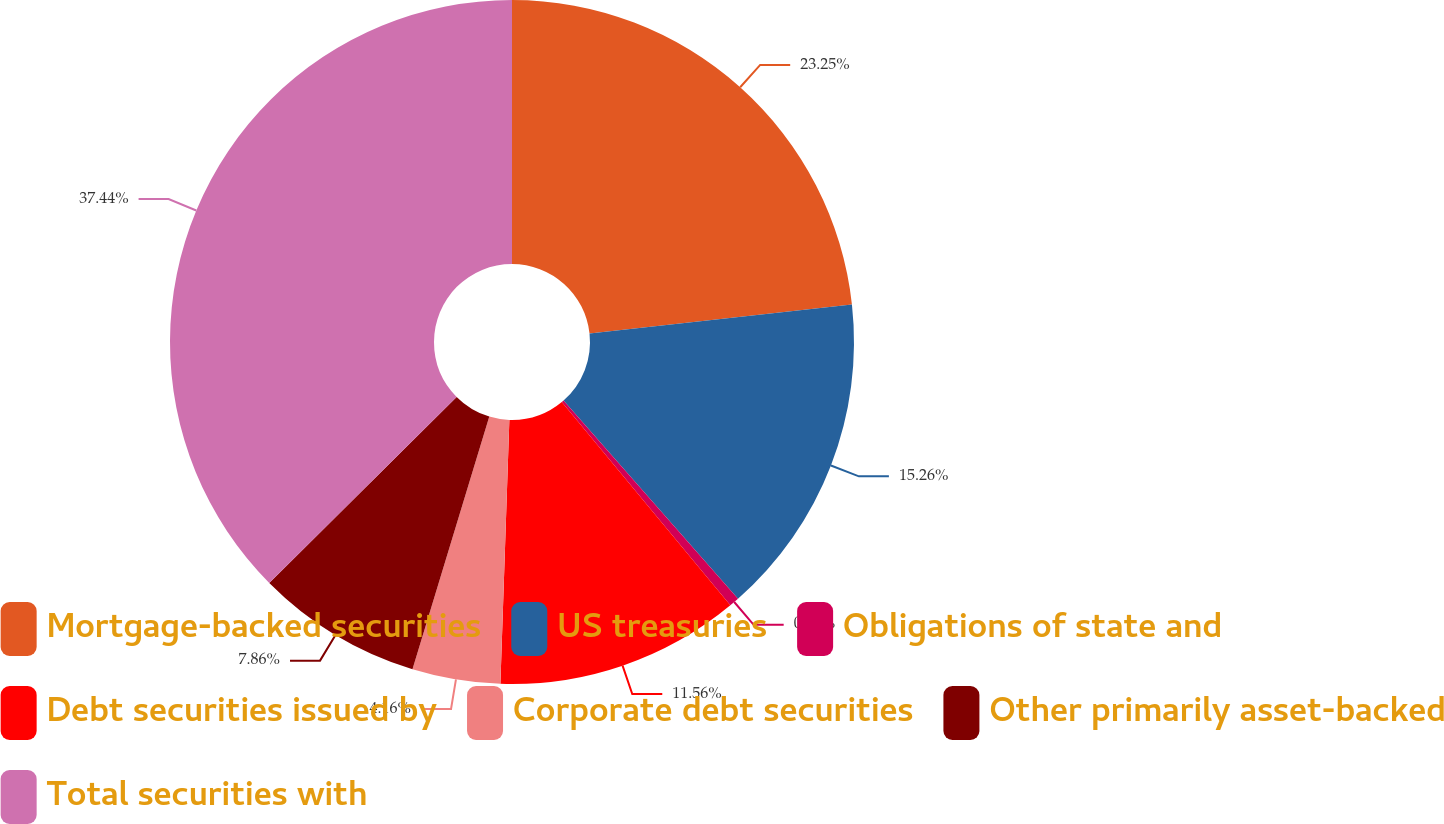Convert chart. <chart><loc_0><loc_0><loc_500><loc_500><pie_chart><fcel>Mortgage-backed securities<fcel>US treasuries<fcel>Obligations of state and<fcel>Debt securities issued by<fcel>Corporate debt securities<fcel>Other primarily asset-backed<fcel>Total securities with<nl><fcel>23.25%<fcel>15.26%<fcel>0.47%<fcel>11.56%<fcel>4.16%<fcel>7.86%<fcel>37.44%<nl></chart> 